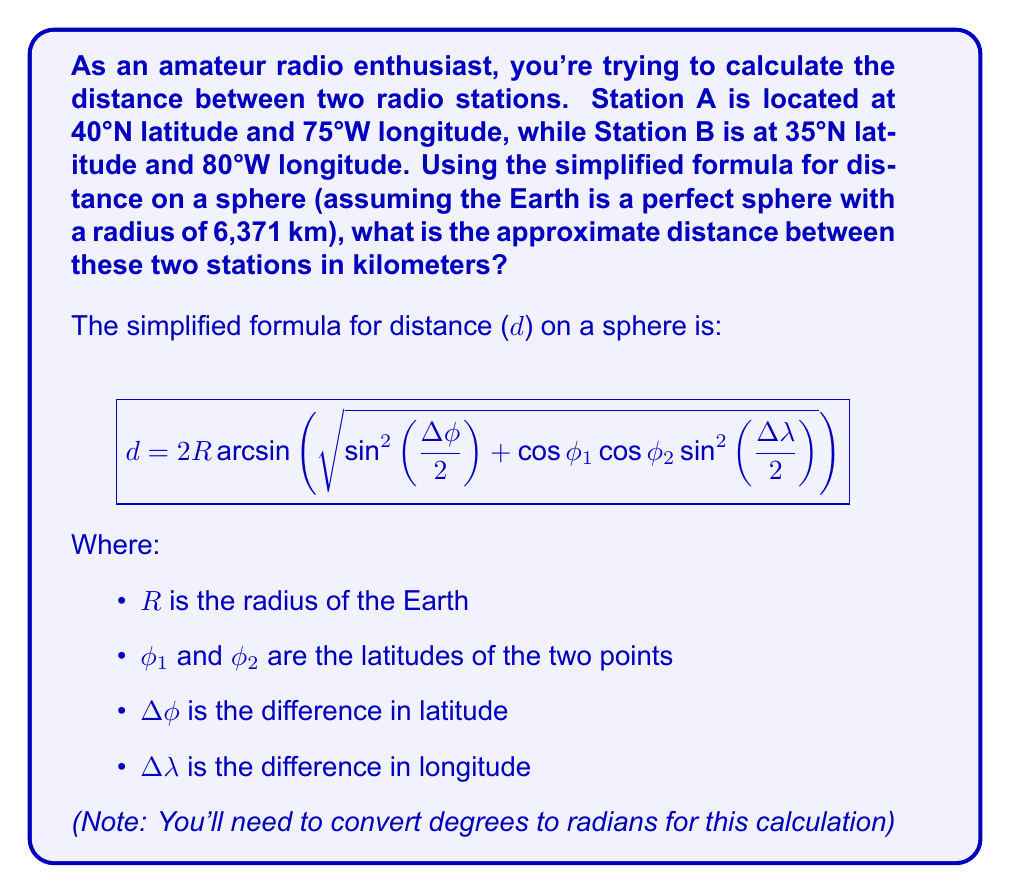Can you answer this question? Let's break this down step-by-step:

1) First, we need to convert our latitudes and longitudes from degrees to radians:
   $\phi_1 = 40° \times \frac{\pi}{180} = 0.6981$ radians
   $\phi_2 = 35° \times \frac{\pi}{180} = 0.6109$ radians
   $\lambda_1 = -75° \times \frac{\pi}{180} = -1.3090$ radians
   $\lambda_2 = -80° \times \frac{\pi}{180} = -1.3963$ radians

2) Calculate $\Delta\phi$ and $\Delta\lambda$:
   $\Delta\phi = \phi_2 - \phi_1 = 0.6109 - 0.6981 = -0.0872$ radians
   $\Delta\lambda = \lambda_2 - \lambda_1 = -1.3963 - (-1.3090) = -0.0873$ radians

3) Now let's plug these values into our formula:

   $$d = 2 \times 6371 \times \arcsin\left(\sqrt{\sin^2\left(\frac{-0.0872}{2}\right) + \cos(0.6981) \cos(0.6109) \sin^2\left(\frac{-0.0873}{2}\right)}\right)$$

4) Let's calculate the parts inside the square root:
   $\sin^2\left(\frac{-0.0872}{2}\right) = 0.00189$
   $\cos(0.6981) \cos(0.6109) = 0.5680$
   $\sin^2\left(\frac{-0.0873}{2}\right) = 0.00190$

5) Putting it all together:
   $$d = 2 \times 6371 \times \arcsin\left(\sqrt{0.00189 + 0.5680 \times 0.00190}\right)$$
   $$d = 12742 \times \arcsin\left(\sqrt{0.00297}\right)$$
   $$d = 12742 \times \arcsin(0.0545)$$
   $$d = 12742 \times 0.0545 = 694.44 \text{ km}$$

Therefore, the approximate distance between the two radio stations is about 694 km.
Answer: 694 km 